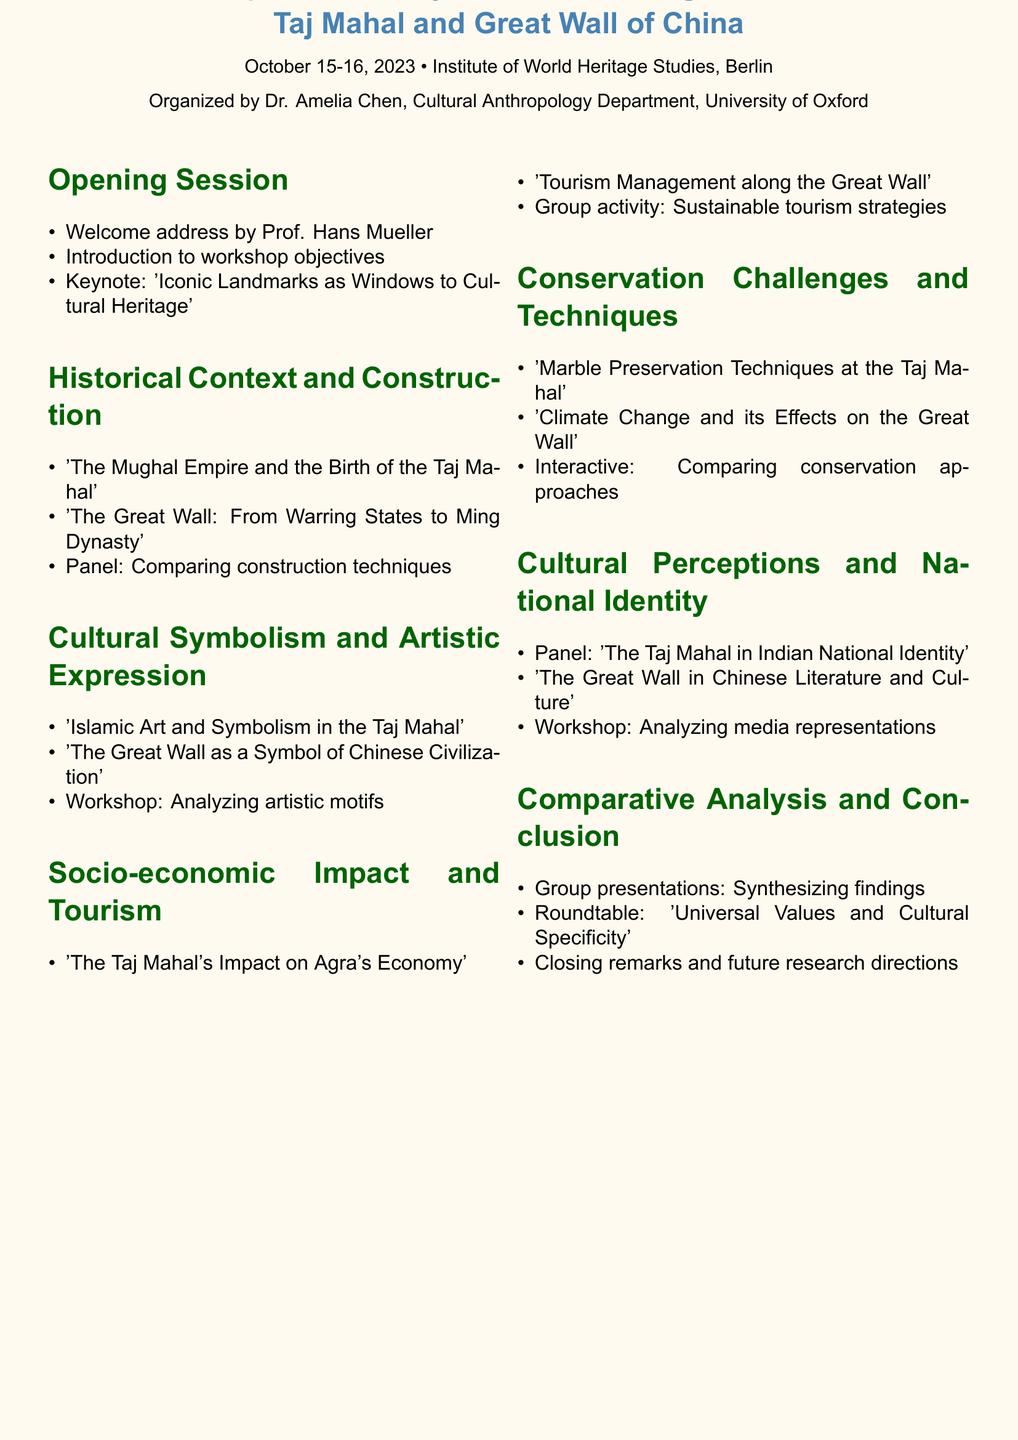What is the workshop title? The workshop title is found in the header of the document, prominently displaying the main theme of the event.
Answer: Comparative Analysis of Cultural Significance: Taj Mahal and Great Wall of China Who is the organizer of the workshop? The organizer is mentioned alongside the workshop details, highlighting their academic affiliation and role in hosting the event.
Answer: Dr. Amelia Chen, Cultural Anthropology Department, University of Oxford What are the dates of the workshop? The dates can be found under the workshop title, indicating the specific days the event will take place.
Answer: October 15-16, 2023 Which university is Prof. Li Xiaoming associated with? This information is located in the historical context and construction section, detailing the speaker's affiliation.
Answer: Tsinghua University What is the focus of the first session? The first session's title indicates the topics covered during this part of the workshop.
Answer: Opening Session Who is giving the keynote speech? The keynote speaker is listed in the opening session of the document, providing insight into the depth of the discussions.
Answer: Dr. Rajesh Gupta What type of activity is included in the socio-economic impact section? The document specifies the format of various segments; one section is dedicated to group activities involving practical contributions from participants.
Answer: Group activity How many sections are in the agenda? The sections can be counted from the organized layout of the workshop, providing a structured understanding of the day's flow.
Answer: Seven What is one of the panels in the cultural perceptions section? The panel discussion is clearly outlined in the document, showing the collaborative aspect of the workshop's themes on identity.
Answer: The Taj Mahal in Indian National Identity What is the theme of the closing session? The last session's title encapsulates the overall goal of synthesizing the workshop findings into final thoughts and future directions.
Answer: Comparative Analysis and Conclusion 